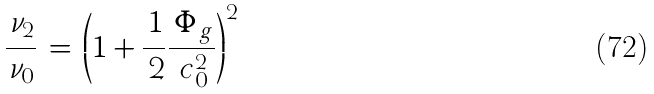<formula> <loc_0><loc_0><loc_500><loc_500>\frac { \, \nu _ { 2 } } { \, \nu _ { 0 } } \, = \, \left ( 1 + \frac { \, 1 } { \, 2 } \frac { \, \Phi _ { \, g } } { \, c _ { 0 } ^ { 2 } } \right ) ^ { 2 }</formula> 